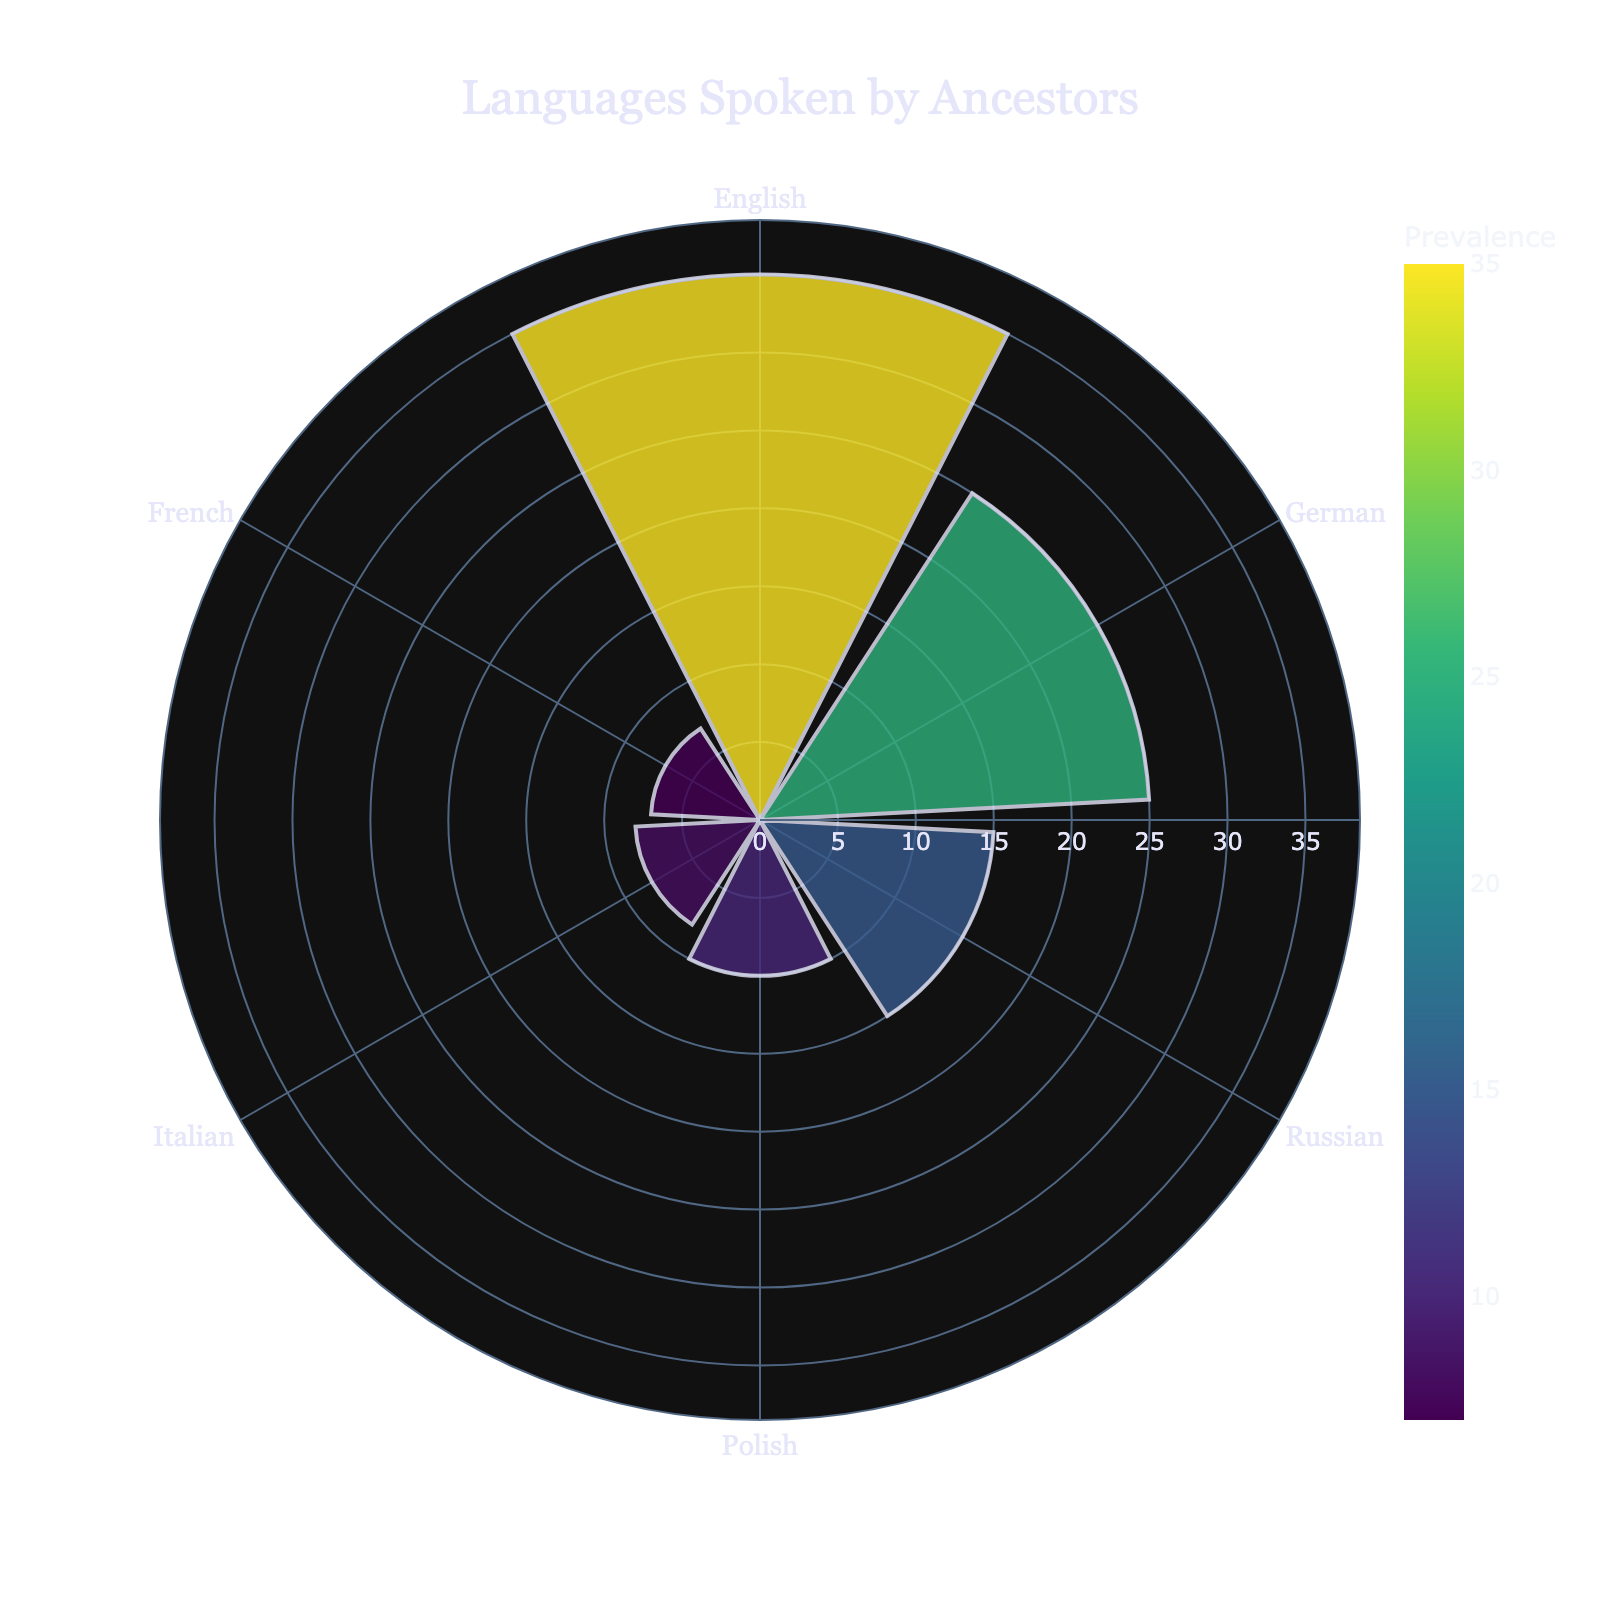What is the title of the chart? The title is typically found at the top center of the chart, indicating the subject it represents. Here, it reads "Languages Spoken by Ancestors."
Answer: Languages Spoken by Ancestors Which language has the highest prevalence? The most prominent segment in the chart, based on length, represents the language with the highest prevalence. In this case, it is English.
Answer: English How many languages are represented in the chart? The chart segments represent individual data points for each language spoken. Counting these sections gives the total number. There are six distinct segments.
Answer: 6 What are the two least spoken languages among the ancestors? The shortest segments in the chart represent the languages with the lowest prevalence. Here, these are French and Italian.
Answer: French and Italian What is the prevalence difference between German and Russian? Identify the segments for German and Russian, then subtract the prevalence of Russian (15) from German (25) to find the difference.
Answer: 10 What is the combined prevalence of Polish and Italian? Locate the prevalence for each language: Polish (10) and Italian (8). Sum these values to find the total prevalence.
Answer: 18 Which languages have a prevalence greater than 20? Determine the languages where the segments extend beyond the 20 mark on the radial axis. Here, they are English (35) and German (25).
Answer: English and German Compare the prevalence of English and German. Which one is more common and by how much? English and German's prevalence are 35 and 25, respectively. Subtract 25 from 35 to determine that English is more common by 10.
Answer: English by 10 What is the average prevalence of all the languages spoken by ancestors? Sum the prevalence values (35, 25, 15, 10, 8, 7) and divide by the number of languages (6). Calculation: (35 + 25 + 15 + 10 + 8 + 7) / 6.
Answer: 16.67 